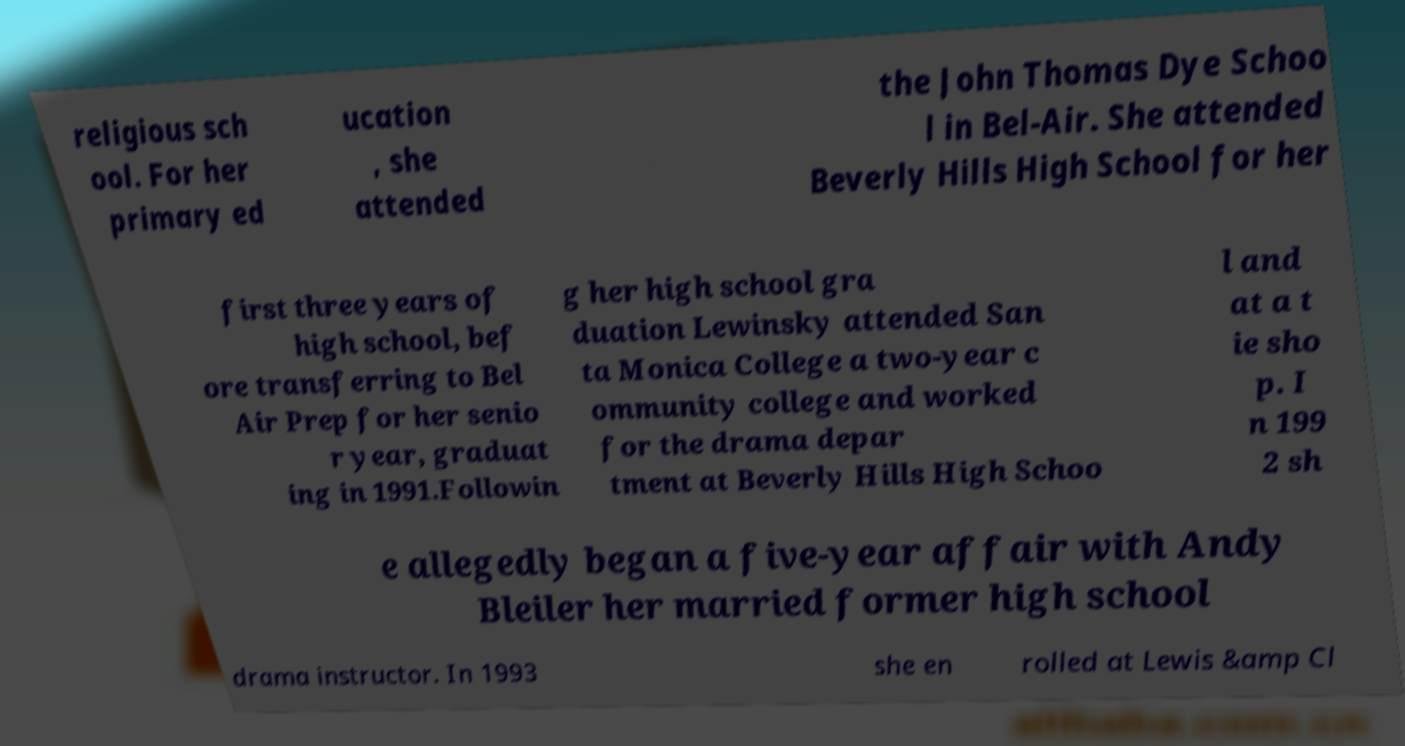Please read and relay the text visible in this image. What does it say? religious sch ool. For her primary ed ucation , she attended the John Thomas Dye Schoo l in Bel-Air. She attended Beverly Hills High School for her first three years of high school, bef ore transferring to Bel Air Prep for her senio r year, graduat ing in 1991.Followin g her high school gra duation Lewinsky attended San ta Monica College a two-year c ommunity college and worked for the drama depar tment at Beverly Hills High Schoo l and at a t ie sho p. I n 199 2 sh e allegedly began a five-year affair with Andy Bleiler her married former high school drama instructor. In 1993 she en rolled at Lewis &amp Cl 